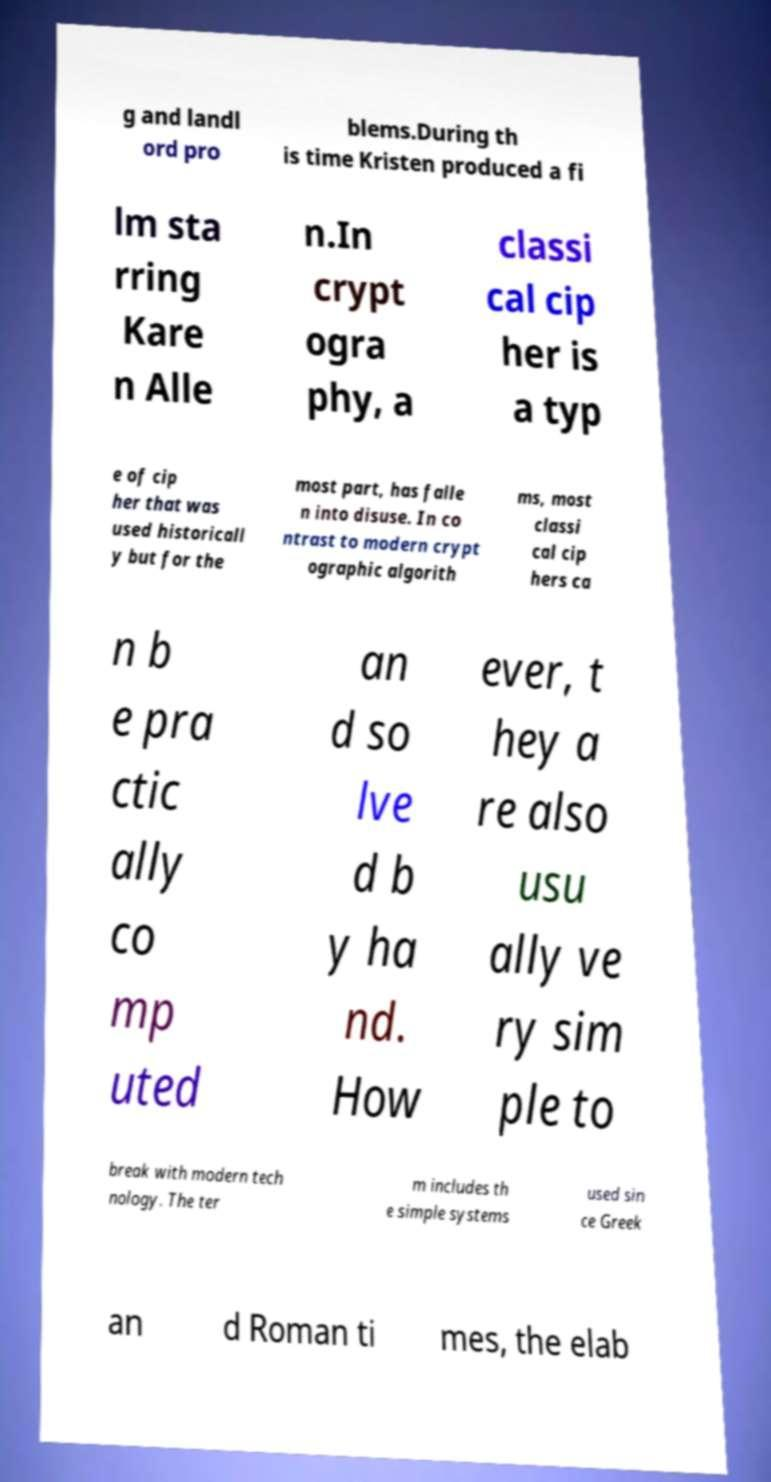What messages or text are displayed in this image? I need them in a readable, typed format. g and landl ord pro blems.During th is time Kristen produced a fi lm sta rring Kare n Alle n.In crypt ogra phy, a classi cal cip her is a typ e of cip her that was used historicall y but for the most part, has falle n into disuse. In co ntrast to modern crypt ographic algorith ms, most classi cal cip hers ca n b e pra ctic ally co mp uted an d so lve d b y ha nd. How ever, t hey a re also usu ally ve ry sim ple to break with modern tech nology. The ter m includes th e simple systems used sin ce Greek an d Roman ti mes, the elab 